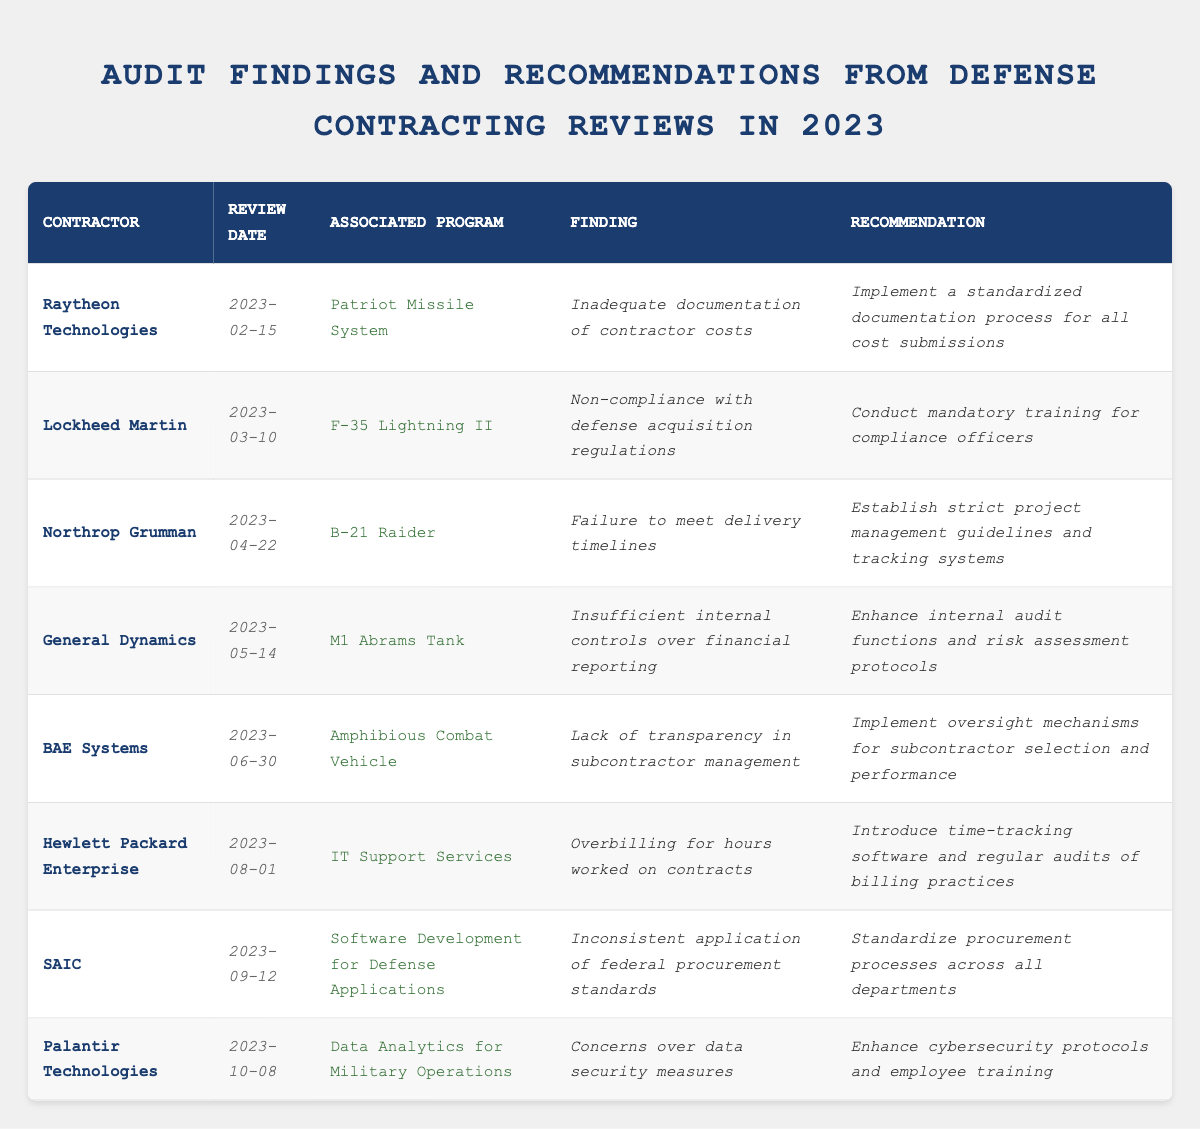What was the finding associated with Raytheon Technologies? The table shows that Raytheon Technologies had the finding of "Inadequate documentation of contractor costs."
Answer: Inadequate documentation of contractor costs Which contractor was reviewed on March 10, 2023? According to the table, Lockheed Martin was reviewed on March 10, 2023.
Answer: Lockheed Martin How many audit findings are listed in the table? The table lists a total of 8 audit findings for different contractors.
Answer: 8 What recommendation was made to Northrop Grumman? The table indicates that Northrop Grumman was recommended to "Establish strict project management guidelines and tracking systems."
Answer: Establish strict project management guidelines and tracking systems Which contractor's finding concerned data security measures? The table shows that the finding concerning data security measures was associated with Palantir Technologies.
Answer: Palantir Technologies Is there a finding related to overbilling for hours worked? Yes, there is a finding related to overbilling for hours worked, specifically for Hewlett Packard Enterprise.
Answer: Yes How many contractors had findings related to internal controls or auditing? There are two contractors, General Dynamics and BAE Systems, whose findings relate to internal controls or auditing.
Answer: 2 Which contractor received a finding regarding delivery timelines? The table indicates that Northrop Grumman received a finding regarding failure to meet delivery timelines.
Answer: Northrop Grumman What is the recommendation given to SAIC? The recommendation given to SAIC is to "Standardize procurement processes across all departments."
Answer: Standardize procurement processes across all departments Which finding occurred last in the sequence of reviews shown? The last finding listed in the table pertains to Palantir Technologies on October 8, 2023.
Answer: Palantir Technologies What is the most common theme of findings among the contractors? Many findings indicate issues with compliance and internal controls, suggesting a common theme of oversight and documentation.
Answer: Oversight and documentation issues 